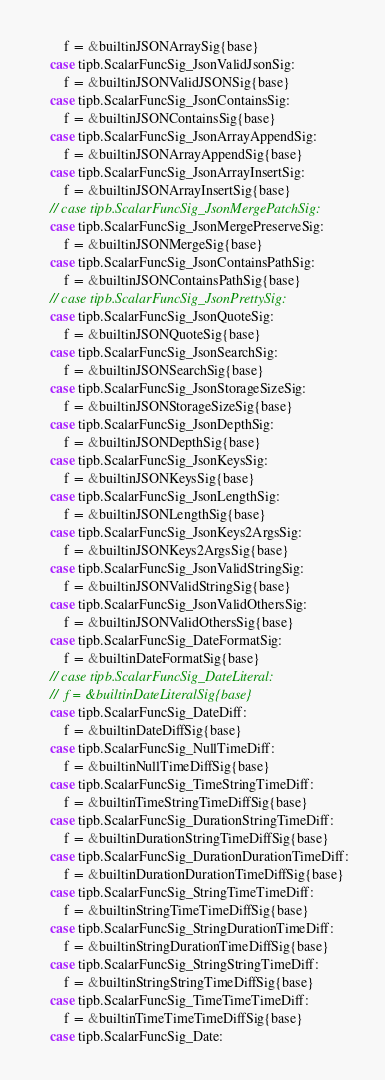<code> <loc_0><loc_0><loc_500><loc_500><_Go_>		f = &builtinJSONArraySig{base}
	case tipb.ScalarFuncSig_JsonValidJsonSig:
		f = &builtinJSONValidJSONSig{base}
	case tipb.ScalarFuncSig_JsonContainsSig:
		f = &builtinJSONContainsSig{base}
	case tipb.ScalarFuncSig_JsonArrayAppendSig:
		f = &builtinJSONArrayAppendSig{base}
	case tipb.ScalarFuncSig_JsonArrayInsertSig:
		f = &builtinJSONArrayInsertSig{base}
	// case tipb.ScalarFuncSig_JsonMergePatchSig:
	case tipb.ScalarFuncSig_JsonMergePreserveSig:
		f = &builtinJSONMergeSig{base}
	case tipb.ScalarFuncSig_JsonContainsPathSig:
		f = &builtinJSONContainsPathSig{base}
	// case tipb.ScalarFuncSig_JsonPrettySig:
	case tipb.ScalarFuncSig_JsonQuoteSig:
		f = &builtinJSONQuoteSig{base}
	case tipb.ScalarFuncSig_JsonSearchSig:
		f = &builtinJSONSearchSig{base}
	case tipb.ScalarFuncSig_JsonStorageSizeSig:
		f = &builtinJSONStorageSizeSig{base}
	case tipb.ScalarFuncSig_JsonDepthSig:
		f = &builtinJSONDepthSig{base}
	case tipb.ScalarFuncSig_JsonKeysSig:
		f = &builtinJSONKeysSig{base}
	case tipb.ScalarFuncSig_JsonLengthSig:
		f = &builtinJSONLengthSig{base}
	case tipb.ScalarFuncSig_JsonKeys2ArgsSig:
		f = &builtinJSONKeys2ArgsSig{base}
	case tipb.ScalarFuncSig_JsonValidStringSig:
		f = &builtinJSONValidStringSig{base}
	case tipb.ScalarFuncSig_JsonValidOthersSig:
		f = &builtinJSONValidOthersSig{base}
	case tipb.ScalarFuncSig_DateFormatSig:
		f = &builtinDateFormatSig{base}
	// case tipb.ScalarFuncSig_DateLiteral:
	// 	f = &builtinDateLiteralSig{base}
	case tipb.ScalarFuncSig_DateDiff:
		f = &builtinDateDiffSig{base}
	case tipb.ScalarFuncSig_NullTimeDiff:
		f = &builtinNullTimeDiffSig{base}
	case tipb.ScalarFuncSig_TimeStringTimeDiff:
		f = &builtinTimeStringTimeDiffSig{base}
	case tipb.ScalarFuncSig_DurationStringTimeDiff:
		f = &builtinDurationStringTimeDiffSig{base}
	case tipb.ScalarFuncSig_DurationDurationTimeDiff:
		f = &builtinDurationDurationTimeDiffSig{base}
	case tipb.ScalarFuncSig_StringTimeTimeDiff:
		f = &builtinStringTimeTimeDiffSig{base}
	case tipb.ScalarFuncSig_StringDurationTimeDiff:
		f = &builtinStringDurationTimeDiffSig{base}
	case tipb.ScalarFuncSig_StringStringTimeDiff:
		f = &builtinStringStringTimeDiffSig{base}
	case tipb.ScalarFuncSig_TimeTimeTimeDiff:
		f = &builtinTimeTimeTimeDiffSig{base}
	case tipb.ScalarFuncSig_Date:</code> 